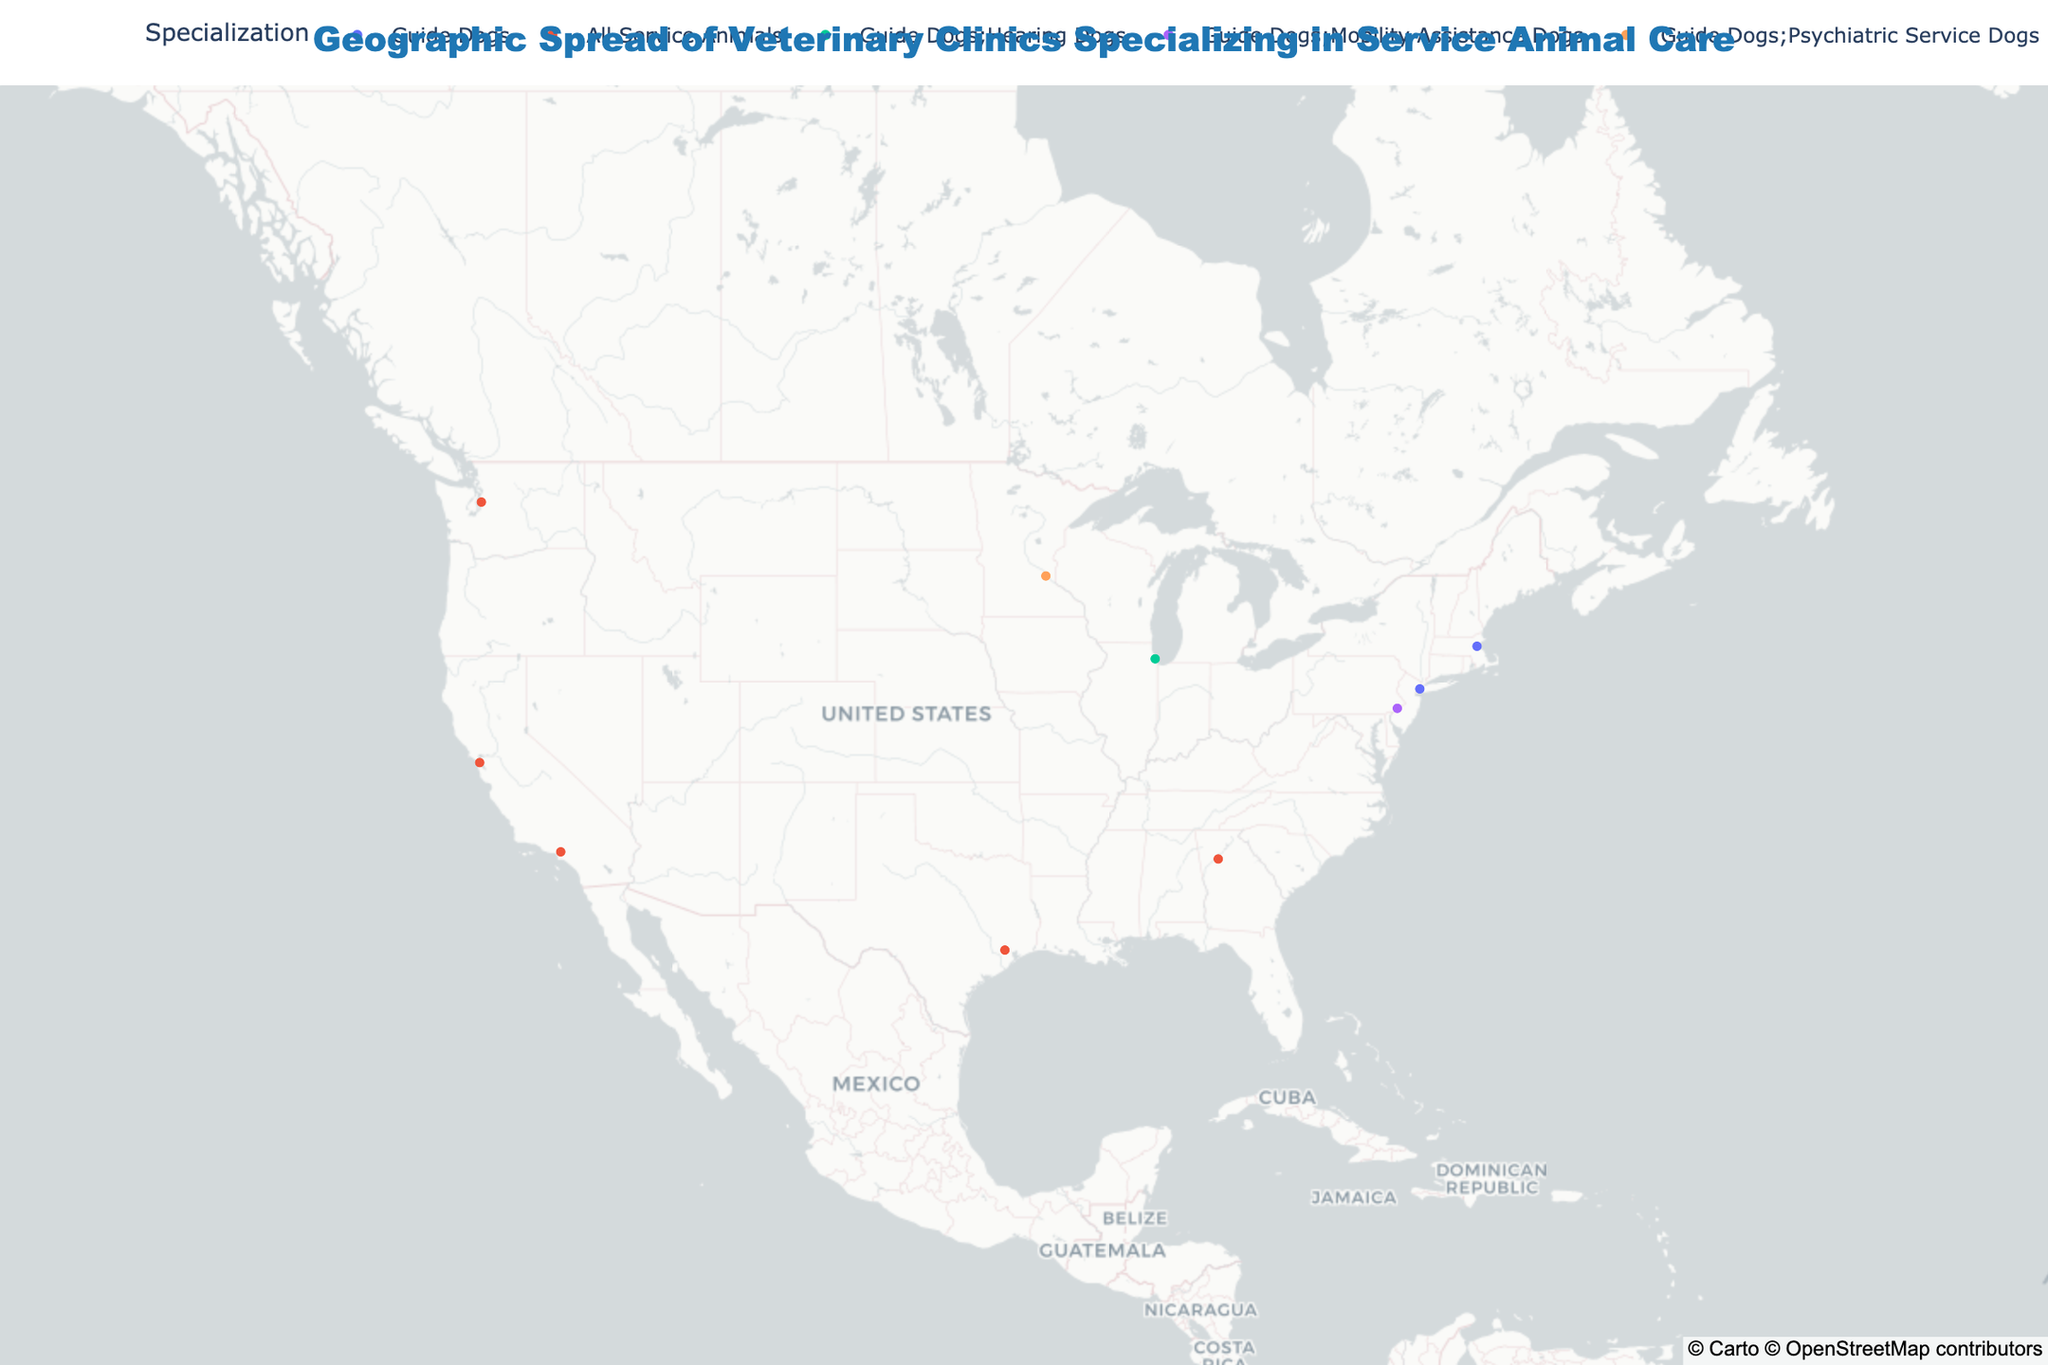What is the title of the figure? The title is displayed at the top of the figure and summarizes the subject of the plot. It helps in understanding what the plot is about immediately.
Answer: Geographic Spread of Veterinary Clinics Specializing in Service Animal Care How many clinics in the figure specialize in care for "All Service Animals"? To answer this, look for the clinics color-coded to represent "All Service Animals" and count them.
Answer: 4 Which city has a clinic that offers "Acupuncture"? Find the city corresponding to the clinic offering "Acupuncture" by looking at the service details shown when hovering over the relevant data point.
Answer: San Francisco How many clinics offer "Regular Check-ups" as a service? All clinics listed provide "Regular Check-ups" as part of their services, so count the total number of clinics.
Answer: 10 Which clinic offers the most diverse range of services? Review the hover data to determine which clinic lists the greatest number of unique services.
Answer: Los Angeles Assistance Animal Hospital What is the westernmost clinic shown in the United States? Identify the clinic with the lowest longitude value to find the westernmost location.
Answer: San Francisco Service Canine Care Which clinics specifically include "Behavioral Assessment" in their services? Look for clinics that document "Behavioral Assessment" as part of their services in the hover data.
Answer: Los Angeles Assistance Animal Hospital, Atlanta Assistance Animal Clinic Compare the clinics in Boston and Minneapolis. Which one offers more services? By checking the hover data for both clinics, count the total services listed for each and compare.
Answer: Boston Guide Dog Wellness Institute How many different types of specializations are represented in the figure? Count the distinct types of specializations listed in the plot legend.
Answer: 5 Is there a clinic in the Midwest that offers "Cold Weather Training"? Find a Midwest city (like Minneapolis) and check if "Cold Weather Training" is among the listed services for the clinic in that city.
Answer: Yes (Minneapolis Helping Paws Hospital) 